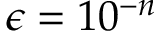Convert formula to latex. <formula><loc_0><loc_0><loc_500><loc_500>\epsilon = 1 0 ^ { - n }</formula> 